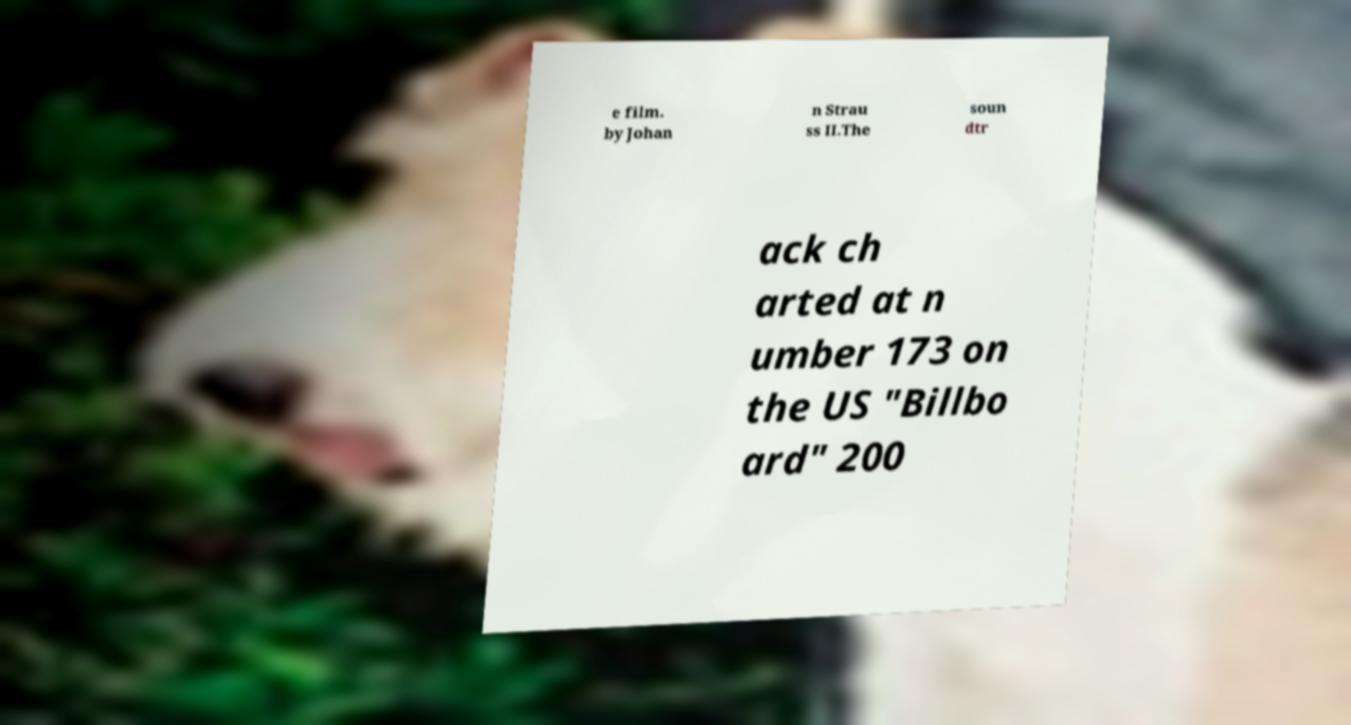Could you assist in decoding the text presented in this image and type it out clearly? e film. by Johan n Strau ss II.The soun dtr ack ch arted at n umber 173 on the US "Billbo ard" 200 